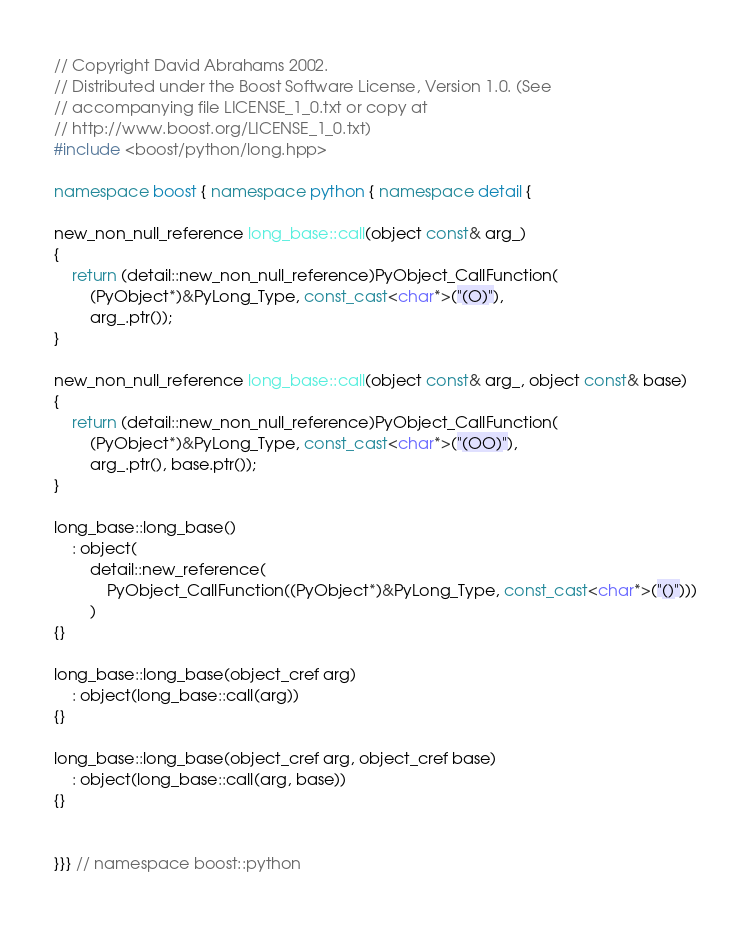<code> <loc_0><loc_0><loc_500><loc_500><_C++_>// Copyright David Abrahams 2002.
// Distributed under the Boost Software License, Version 1.0. (See
// accompanying file LICENSE_1_0.txt or copy at
// http://www.boost.org/LICENSE_1_0.txt)
#include <boost/python/long.hpp>

namespace boost { namespace python { namespace detail {

new_non_null_reference long_base::call(object const& arg_)
{
    return (detail::new_non_null_reference)PyObject_CallFunction(
        (PyObject*)&PyLong_Type, const_cast<char*>("(O)"),
        arg_.ptr());
}

new_non_null_reference long_base::call(object const& arg_, object const& base)
{
    return (detail::new_non_null_reference)PyObject_CallFunction(
        (PyObject*)&PyLong_Type, const_cast<char*>("(OO)"),
        arg_.ptr(), base.ptr());
}

long_base::long_base()
    : object(
        detail::new_reference(
            PyObject_CallFunction((PyObject*)&PyLong_Type, const_cast<char*>("()")))
        )
{}

long_base::long_base(object_cref arg)
    : object(long_base::call(arg))
{}

long_base::long_base(object_cref arg, object_cref base)
    : object(long_base::call(arg, base))
{}


}}} // namespace boost::python
</code> 